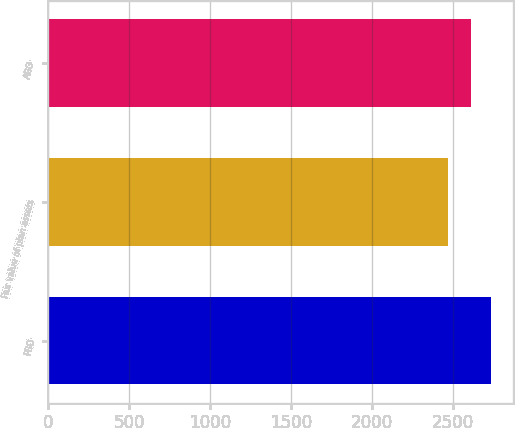<chart> <loc_0><loc_0><loc_500><loc_500><bar_chart><fcel>PBO<fcel>Fair value of plan assets<fcel>ABO<nl><fcel>2733.6<fcel>2467.5<fcel>2608.6<nl></chart> 